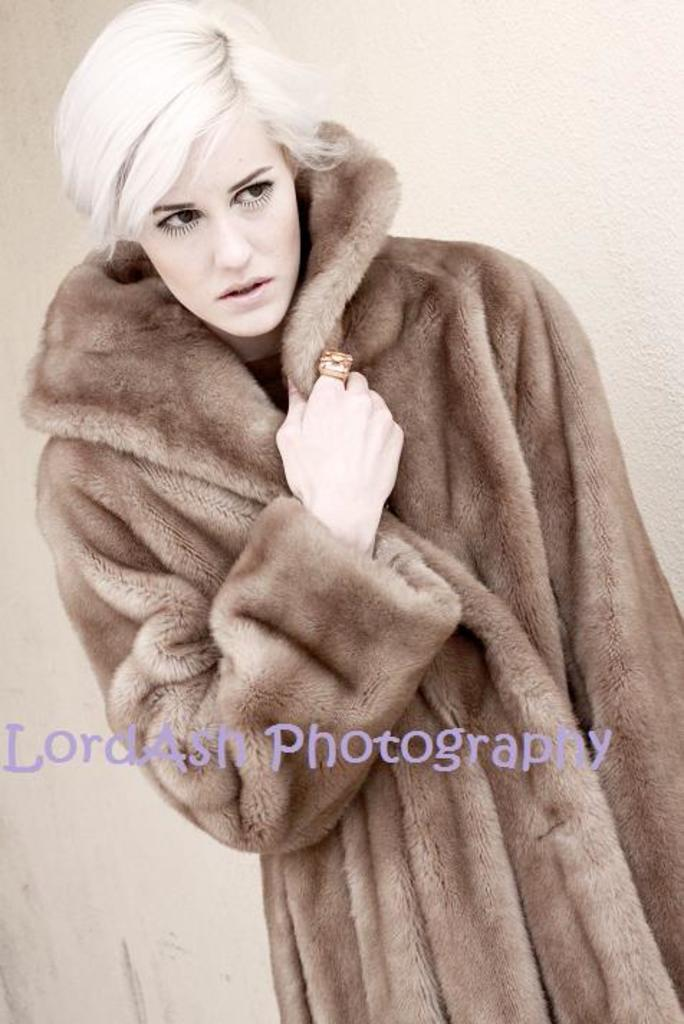Who is present in the image? There is a woman in the image. What is the woman doing in the image? The woman is standing. What is the woman wearing in the image? The woman is wearing a sweater. What else can be seen in the image besides the woman? There is text in the middle of the image. Are there any cows visible in the image? No, there are no cows present in the image. 